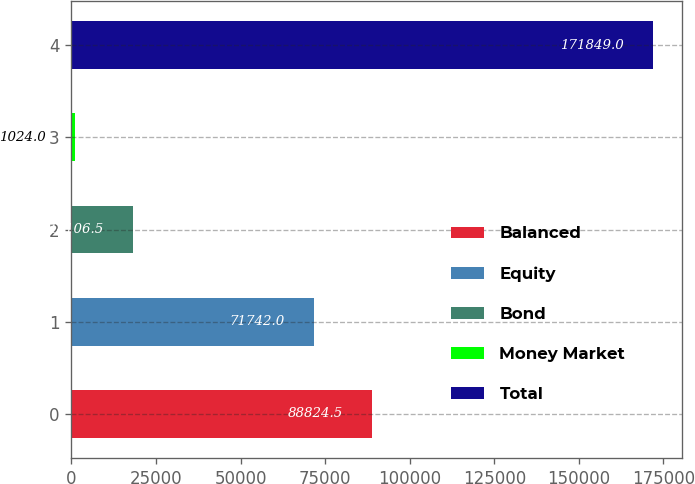Convert chart to OTSL. <chart><loc_0><loc_0><loc_500><loc_500><bar_chart><fcel>Balanced<fcel>Equity<fcel>Bond<fcel>Money Market<fcel>Total<nl><fcel>88824.5<fcel>71742<fcel>18106.5<fcel>1024<fcel>171849<nl></chart> 